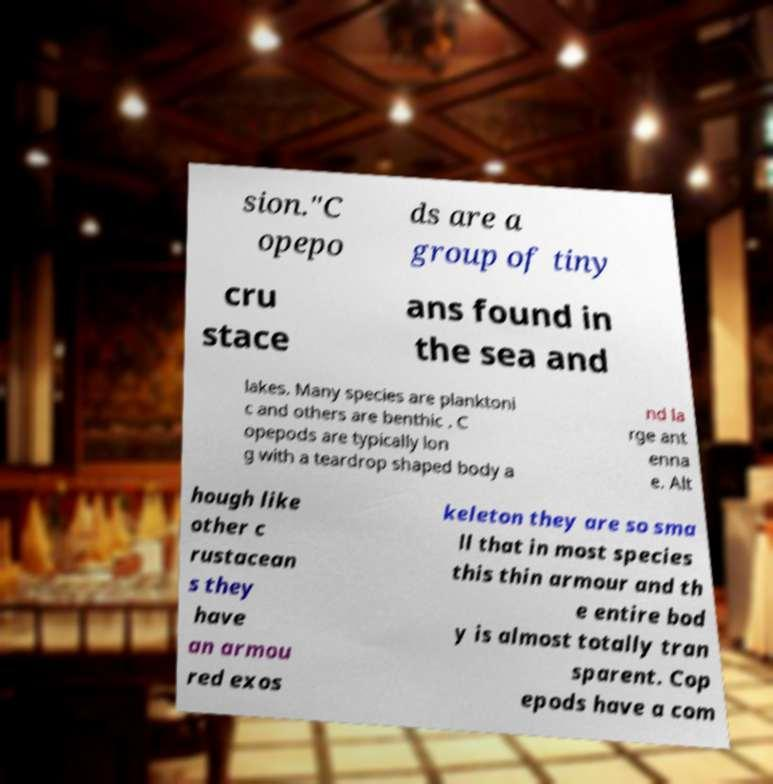Please identify and transcribe the text found in this image. sion."C opepo ds are a group of tiny cru stace ans found in the sea and lakes. Many species are planktoni c and others are benthic . C opepods are typically lon g with a teardrop shaped body a nd la rge ant enna e. Alt hough like other c rustacean s they have an armou red exos keleton they are so sma ll that in most species this thin armour and th e entire bod y is almost totally tran sparent. Cop epods have a com 